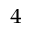Convert formula to latex. <formula><loc_0><loc_0><loc_500><loc_500>^ { 4 }</formula> 